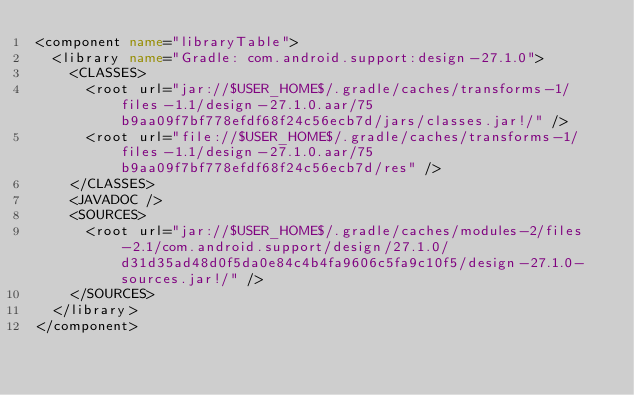Convert code to text. <code><loc_0><loc_0><loc_500><loc_500><_XML_><component name="libraryTable">
  <library name="Gradle: com.android.support:design-27.1.0">
    <CLASSES>
      <root url="jar://$USER_HOME$/.gradle/caches/transforms-1/files-1.1/design-27.1.0.aar/75b9aa09f7bf778efdf68f24c56ecb7d/jars/classes.jar!/" />
      <root url="file://$USER_HOME$/.gradle/caches/transforms-1/files-1.1/design-27.1.0.aar/75b9aa09f7bf778efdf68f24c56ecb7d/res" />
    </CLASSES>
    <JAVADOC />
    <SOURCES>
      <root url="jar://$USER_HOME$/.gradle/caches/modules-2/files-2.1/com.android.support/design/27.1.0/d31d35ad48d0f5da0e84c4b4fa9606c5fa9c10f5/design-27.1.0-sources.jar!/" />
    </SOURCES>
  </library>
</component></code> 